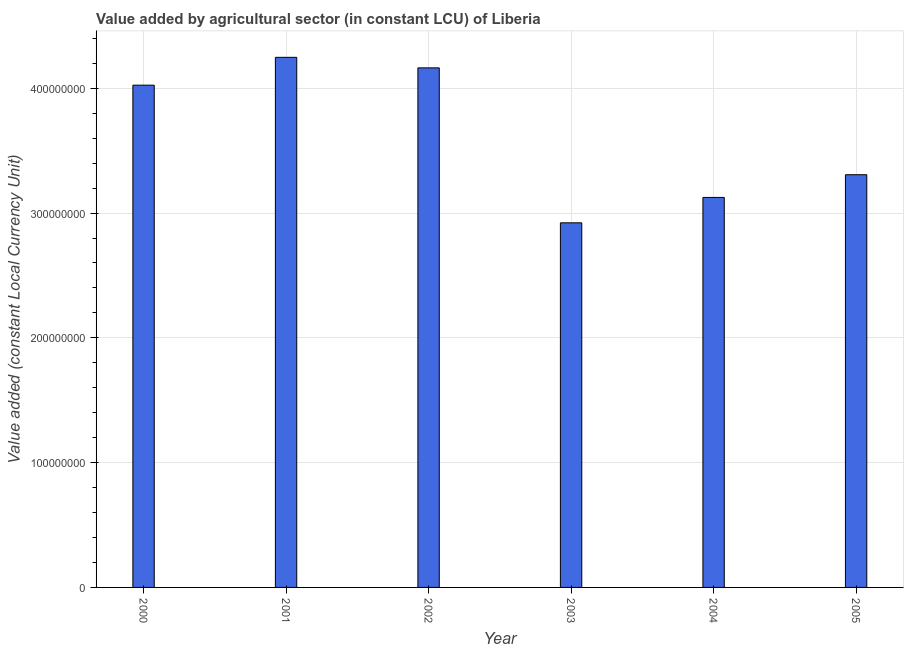Does the graph contain any zero values?
Provide a short and direct response. No. Does the graph contain grids?
Provide a short and direct response. Yes. What is the title of the graph?
Offer a very short reply. Value added by agricultural sector (in constant LCU) of Liberia. What is the label or title of the X-axis?
Your response must be concise. Year. What is the label or title of the Y-axis?
Keep it short and to the point. Value added (constant Local Currency Unit). What is the value added by agriculture sector in 2004?
Your answer should be compact. 3.13e+08. Across all years, what is the maximum value added by agriculture sector?
Offer a very short reply. 4.25e+08. Across all years, what is the minimum value added by agriculture sector?
Keep it short and to the point. 2.92e+08. In which year was the value added by agriculture sector maximum?
Make the answer very short. 2001. What is the sum of the value added by agriculture sector?
Ensure brevity in your answer.  2.18e+09. What is the difference between the value added by agriculture sector in 2001 and 2005?
Keep it short and to the point. 9.41e+07. What is the average value added by agriculture sector per year?
Your answer should be very brief. 3.63e+08. What is the median value added by agriculture sector?
Provide a short and direct response. 3.67e+08. What is the ratio of the value added by agriculture sector in 2004 to that in 2005?
Provide a succinct answer. 0.94. Is the difference between the value added by agriculture sector in 2002 and 2003 greater than the difference between any two years?
Keep it short and to the point. No. What is the difference between the highest and the second highest value added by agriculture sector?
Make the answer very short. 8.45e+06. What is the difference between the highest and the lowest value added by agriculture sector?
Your response must be concise. 1.33e+08. In how many years, is the value added by agriculture sector greater than the average value added by agriculture sector taken over all years?
Your response must be concise. 3. How many bars are there?
Offer a very short reply. 6. What is the Value added (constant Local Currency Unit) in 2000?
Provide a succinct answer. 4.02e+08. What is the Value added (constant Local Currency Unit) of 2001?
Give a very brief answer. 4.25e+08. What is the Value added (constant Local Currency Unit) of 2002?
Your response must be concise. 4.16e+08. What is the Value added (constant Local Currency Unit) of 2003?
Offer a very short reply. 2.92e+08. What is the Value added (constant Local Currency Unit) in 2004?
Ensure brevity in your answer.  3.13e+08. What is the Value added (constant Local Currency Unit) in 2005?
Ensure brevity in your answer.  3.31e+08. What is the difference between the Value added (constant Local Currency Unit) in 2000 and 2001?
Make the answer very short. -2.23e+07. What is the difference between the Value added (constant Local Currency Unit) in 2000 and 2002?
Provide a succinct answer. -1.39e+07. What is the difference between the Value added (constant Local Currency Unit) in 2000 and 2003?
Keep it short and to the point. 1.10e+08. What is the difference between the Value added (constant Local Currency Unit) in 2000 and 2004?
Your answer should be very brief. 9.00e+07. What is the difference between the Value added (constant Local Currency Unit) in 2000 and 2005?
Offer a terse response. 7.18e+07. What is the difference between the Value added (constant Local Currency Unit) in 2001 and 2002?
Make the answer very short. 8.45e+06. What is the difference between the Value added (constant Local Currency Unit) in 2001 and 2003?
Provide a succinct answer. 1.33e+08. What is the difference between the Value added (constant Local Currency Unit) in 2001 and 2004?
Offer a terse response. 1.12e+08. What is the difference between the Value added (constant Local Currency Unit) in 2001 and 2005?
Ensure brevity in your answer.  9.41e+07. What is the difference between the Value added (constant Local Currency Unit) in 2002 and 2003?
Make the answer very short. 1.24e+08. What is the difference between the Value added (constant Local Currency Unit) in 2002 and 2004?
Keep it short and to the point. 1.04e+08. What is the difference between the Value added (constant Local Currency Unit) in 2002 and 2005?
Make the answer very short. 8.56e+07. What is the difference between the Value added (constant Local Currency Unit) in 2003 and 2004?
Make the answer very short. -2.04e+07. What is the difference between the Value added (constant Local Currency Unit) in 2003 and 2005?
Offer a very short reply. -3.85e+07. What is the difference between the Value added (constant Local Currency Unit) in 2004 and 2005?
Your answer should be compact. -1.82e+07. What is the ratio of the Value added (constant Local Currency Unit) in 2000 to that in 2001?
Your response must be concise. 0.95. What is the ratio of the Value added (constant Local Currency Unit) in 2000 to that in 2002?
Your answer should be very brief. 0.97. What is the ratio of the Value added (constant Local Currency Unit) in 2000 to that in 2003?
Your response must be concise. 1.38. What is the ratio of the Value added (constant Local Currency Unit) in 2000 to that in 2004?
Provide a short and direct response. 1.29. What is the ratio of the Value added (constant Local Currency Unit) in 2000 to that in 2005?
Keep it short and to the point. 1.22. What is the ratio of the Value added (constant Local Currency Unit) in 2001 to that in 2002?
Make the answer very short. 1.02. What is the ratio of the Value added (constant Local Currency Unit) in 2001 to that in 2003?
Provide a short and direct response. 1.45. What is the ratio of the Value added (constant Local Currency Unit) in 2001 to that in 2004?
Ensure brevity in your answer.  1.36. What is the ratio of the Value added (constant Local Currency Unit) in 2001 to that in 2005?
Provide a succinct answer. 1.28. What is the ratio of the Value added (constant Local Currency Unit) in 2002 to that in 2003?
Ensure brevity in your answer.  1.43. What is the ratio of the Value added (constant Local Currency Unit) in 2002 to that in 2004?
Provide a short and direct response. 1.33. What is the ratio of the Value added (constant Local Currency Unit) in 2002 to that in 2005?
Offer a very short reply. 1.26. What is the ratio of the Value added (constant Local Currency Unit) in 2003 to that in 2004?
Make the answer very short. 0.94. What is the ratio of the Value added (constant Local Currency Unit) in 2003 to that in 2005?
Your response must be concise. 0.88. What is the ratio of the Value added (constant Local Currency Unit) in 2004 to that in 2005?
Your answer should be very brief. 0.94. 